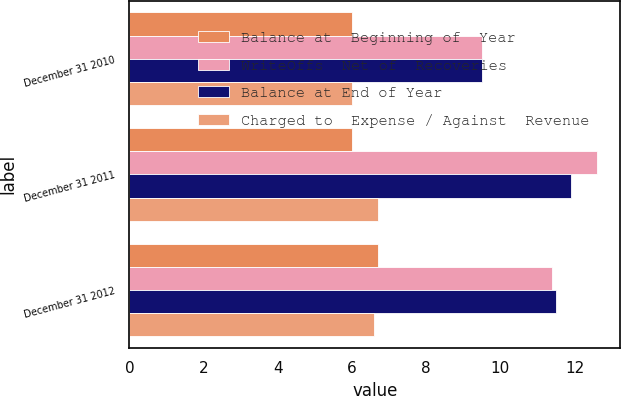Convert chart. <chart><loc_0><loc_0><loc_500><loc_500><stacked_bar_chart><ecel><fcel>December 31 2010<fcel>December 31 2011<fcel>December 31 2012<nl><fcel>Balance at  Beginning of  Year<fcel>6<fcel>6<fcel>6.7<nl><fcel>WriteOffs  Net of  Recoveries<fcel>9.5<fcel>12.6<fcel>11.4<nl><fcel>Balance at End of Year<fcel>9.5<fcel>11.9<fcel>11.5<nl><fcel>Charged to  Expense / Against  Revenue<fcel>6<fcel>6.7<fcel>6.6<nl></chart> 